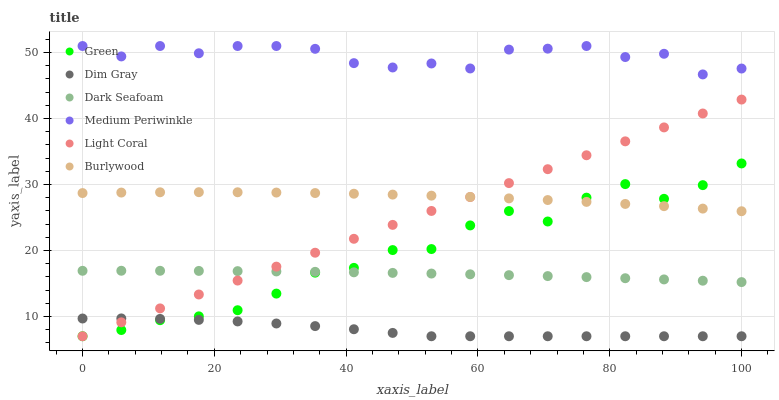Does Dim Gray have the minimum area under the curve?
Answer yes or no. Yes. Does Medium Periwinkle have the maximum area under the curve?
Answer yes or no. Yes. Does Burlywood have the minimum area under the curve?
Answer yes or no. No. Does Burlywood have the maximum area under the curve?
Answer yes or no. No. Is Light Coral the smoothest?
Answer yes or no. Yes. Is Green the roughest?
Answer yes or no. Yes. Is Burlywood the smoothest?
Answer yes or no. No. Is Burlywood the roughest?
Answer yes or no. No. Does Dim Gray have the lowest value?
Answer yes or no. Yes. Does Burlywood have the lowest value?
Answer yes or no. No. Does Medium Periwinkle have the highest value?
Answer yes or no. Yes. Does Burlywood have the highest value?
Answer yes or no. No. Is Burlywood less than Medium Periwinkle?
Answer yes or no. Yes. Is Medium Periwinkle greater than Burlywood?
Answer yes or no. Yes. Does Light Coral intersect Green?
Answer yes or no. Yes. Is Light Coral less than Green?
Answer yes or no. No. Is Light Coral greater than Green?
Answer yes or no. No. Does Burlywood intersect Medium Periwinkle?
Answer yes or no. No. 